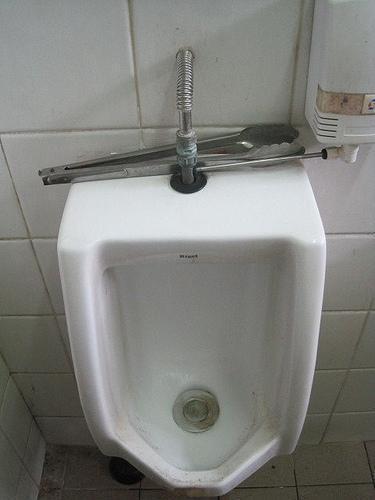How many urinals are in the photo?
Give a very brief answer. 1. 